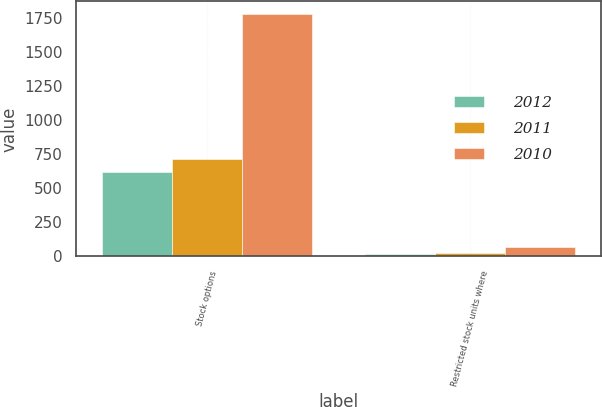Convert chart. <chart><loc_0><loc_0><loc_500><loc_500><stacked_bar_chart><ecel><fcel>Stock options<fcel>Restricted stock units where<nl><fcel>2012<fcel>619<fcel>19<nl><fcel>2011<fcel>711<fcel>22<nl><fcel>2010<fcel>1781<fcel>69<nl></chart> 